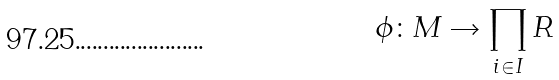Convert formula to latex. <formula><loc_0><loc_0><loc_500><loc_500>\phi \colon M \rightarrow \prod _ { i \in I } R</formula> 